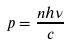<formula> <loc_0><loc_0><loc_500><loc_500>p = \frac { n h \nu } { c }</formula> 